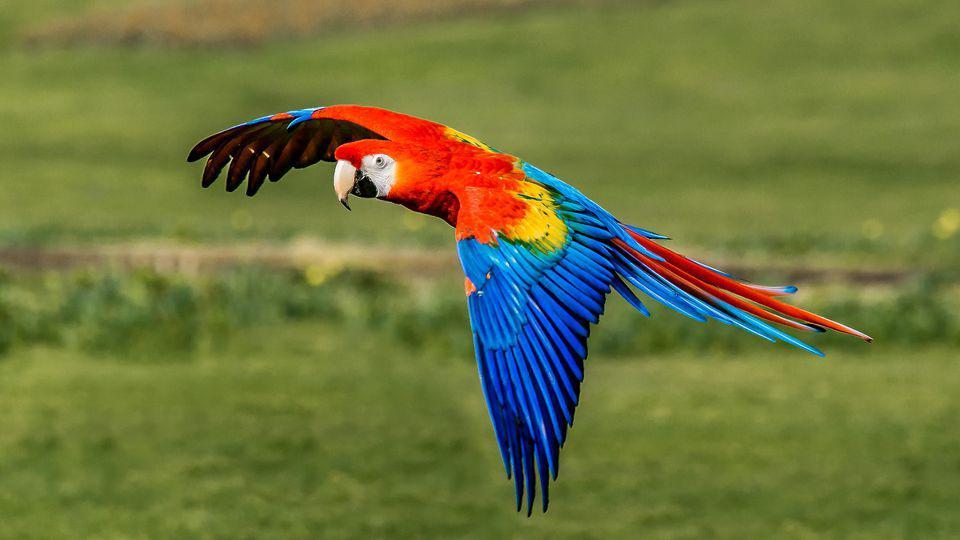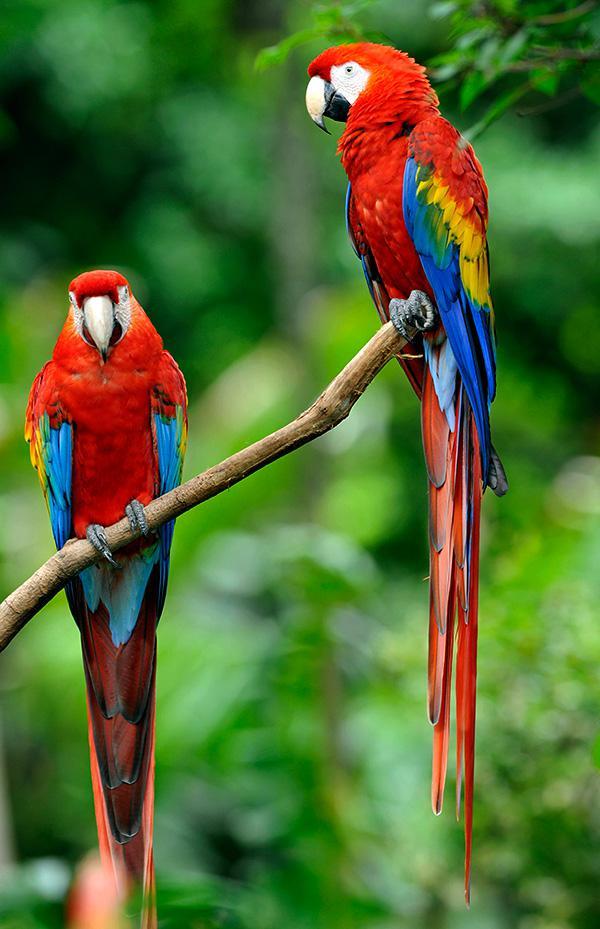The first image is the image on the left, the second image is the image on the right. For the images shown, is this caption "One of the images shows a red, yellow and blue parrot flying." true? Answer yes or no. Yes. The first image is the image on the left, the second image is the image on the right. Assess this claim about the two images: "There are a total of three birds.". Correct or not? Answer yes or no. Yes. 